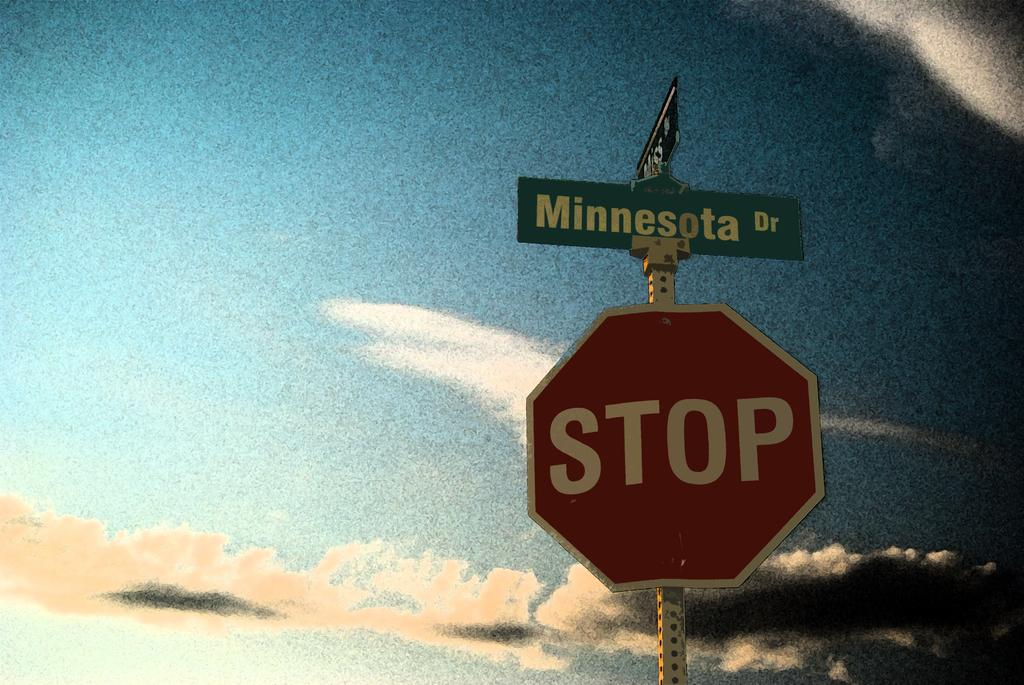What is the main object in the image? There is a pole in the image. What is attached to the pole? There is a stop board and another board with "minnesota" written on it attached to the pole. How many stars can be seen flying around the pole in the image? There are no stars visible in the image, and therefore no stars can be seen flying around the pole. 